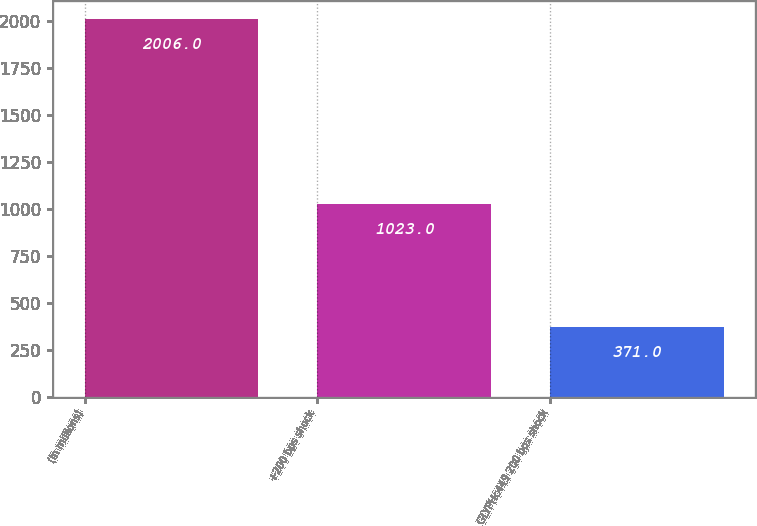<chart> <loc_0><loc_0><loc_500><loc_500><bar_chart><fcel>(In millions)<fcel>+200 bps shock<fcel>GLYPHc449 200 bps shock<nl><fcel>2006<fcel>1023<fcel>371<nl></chart> 